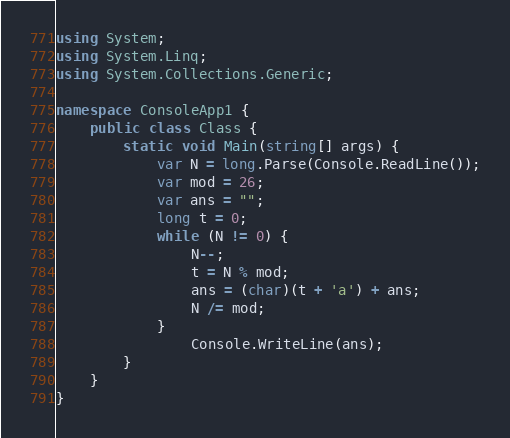<code> <loc_0><loc_0><loc_500><loc_500><_C#_>using System;
using System.Linq;
using System.Collections.Generic;

namespace ConsoleApp1 {
    public class Class {
        static void Main(string[] args) {
            var N = long.Parse(Console.ReadLine());
            var mod = 26;
            var ans = "";
            long t = 0;
            while (N != 0) {
                N--;
                t = N % mod;
                ans = (char)(t + 'a') + ans;
                N /= mod;
            }
                Console.WriteLine(ans);
        }
    }
}</code> 